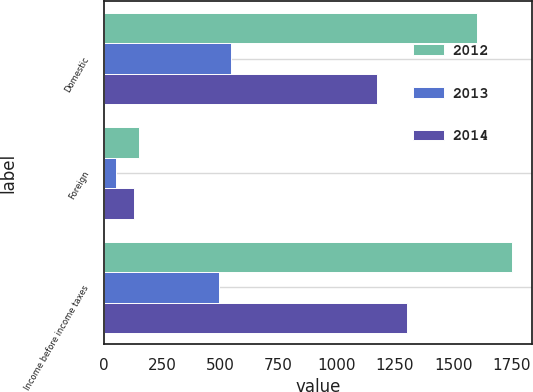<chart> <loc_0><loc_0><loc_500><loc_500><stacked_bar_chart><ecel><fcel>Domestic<fcel>Foreign<fcel>Income before income taxes<nl><fcel>2012<fcel>1601<fcel>150<fcel>1751<nl><fcel>2013<fcel>548<fcel>54<fcel>494<nl><fcel>2014<fcel>1175<fcel>128<fcel>1303<nl></chart> 